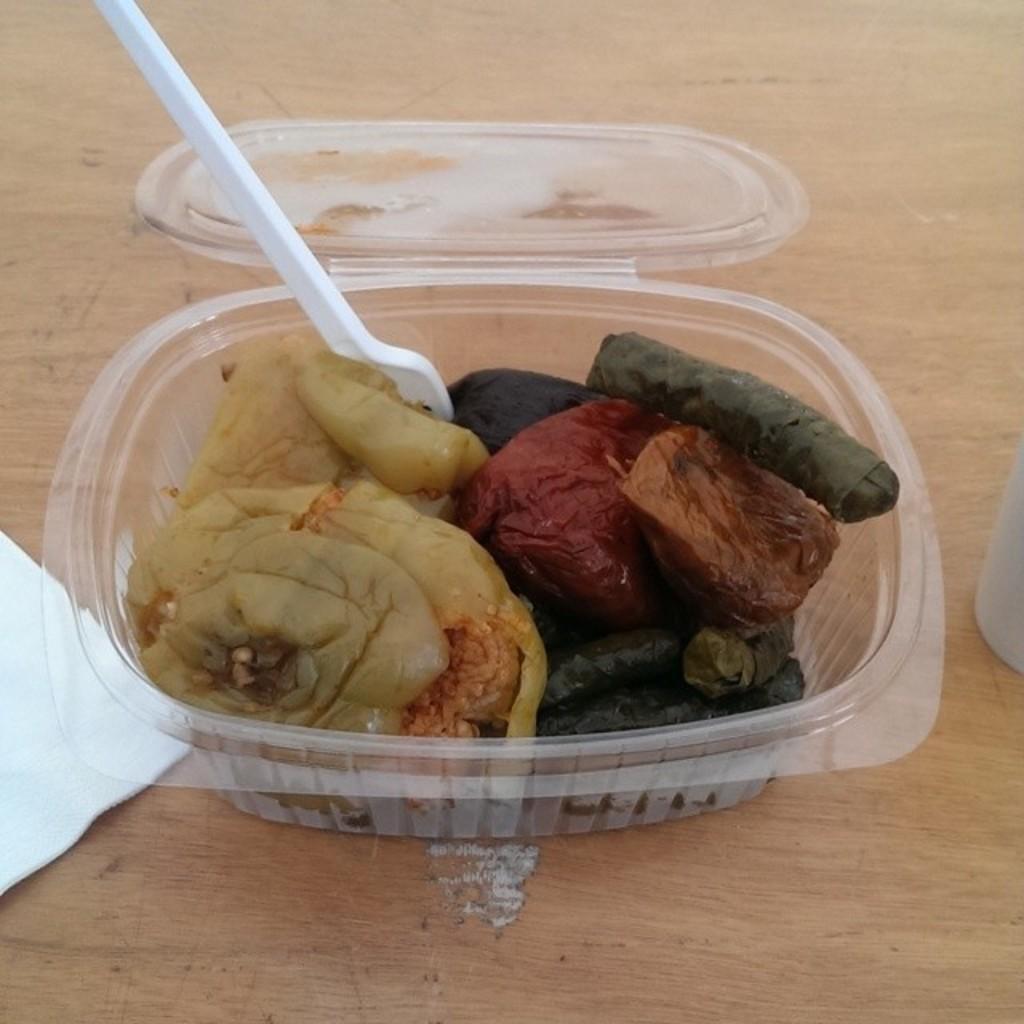Can you describe this image briefly? In this image I see the box on which there is food which is of cream, red, green and orange in color and I see the white color spoon over here and I see the white tissue over here and these all things are on the brown color surface. 